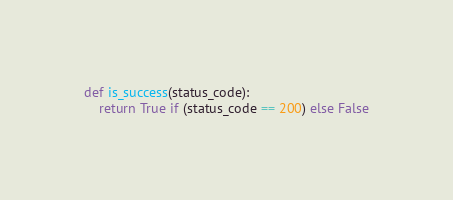Convert code to text. <code><loc_0><loc_0><loc_500><loc_500><_Python_>def is_success(status_code):
    return True if (status_code == 200) else False
</code> 